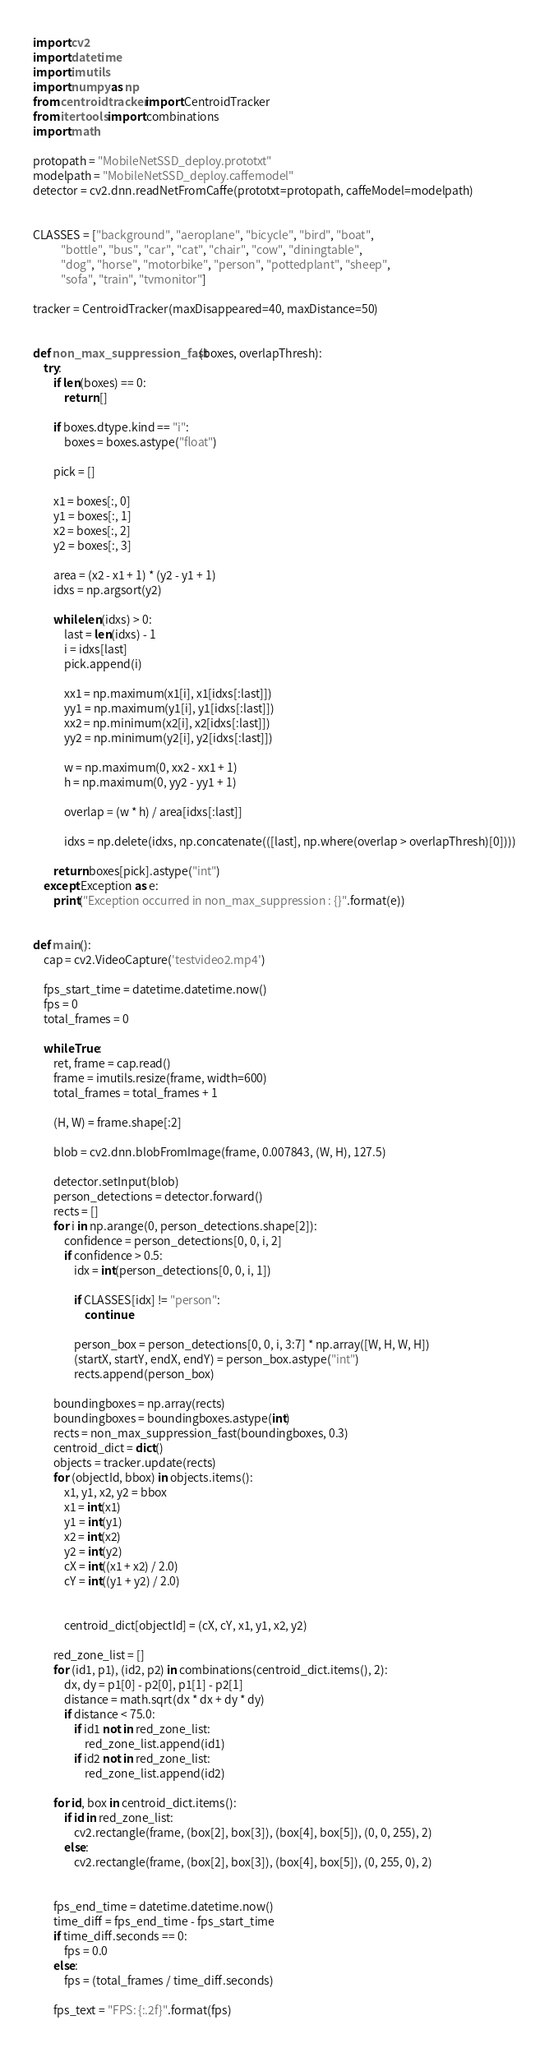Convert code to text. <code><loc_0><loc_0><loc_500><loc_500><_Python_>import cv2
import datetime
import imutils
import numpy as np
from centroidtracker import CentroidTracker
from itertools import combinations
import math

protopath = "MobileNetSSD_deploy.prototxt"
modelpath = "MobileNetSSD_deploy.caffemodel"
detector = cv2.dnn.readNetFromCaffe(prototxt=protopath, caffeModel=modelpath)


CLASSES = ["background", "aeroplane", "bicycle", "bird", "boat",
           "bottle", "bus", "car", "cat", "chair", "cow", "diningtable",
           "dog", "horse", "motorbike", "person", "pottedplant", "sheep",
           "sofa", "train", "tvmonitor"]

tracker = CentroidTracker(maxDisappeared=40, maxDistance=50)


def non_max_suppression_fast(boxes, overlapThresh):
    try:
        if len(boxes) == 0:
            return []

        if boxes.dtype.kind == "i":
            boxes = boxes.astype("float")

        pick = []

        x1 = boxes[:, 0]
        y1 = boxes[:, 1]
        x2 = boxes[:, 2]
        y2 = boxes[:, 3]

        area = (x2 - x1 + 1) * (y2 - y1 + 1)
        idxs = np.argsort(y2)

        while len(idxs) > 0:
            last = len(idxs) - 1
            i = idxs[last]
            pick.append(i)

            xx1 = np.maximum(x1[i], x1[idxs[:last]])
            yy1 = np.maximum(y1[i], y1[idxs[:last]])
            xx2 = np.minimum(x2[i], x2[idxs[:last]])
            yy2 = np.minimum(y2[i], y2[idxs[:last]])

            w = np.maximum(0, xx2 - xx1 + 1)
            h = np.maximum(0, yy2 - yy1 + 1)

            overlap = (w * h) / area[idxs[:last]]

            idxs = np.delete(idxs, np.concatenate(([last], np.where(overlap > overlapThresh)[0])))

        return boxes[pick].astype("int")
    except Exception as e:
        print("Exception occurred in non_max_suppression : {}".format(e))


def main():
    cap = cv2.VideoCapture('testvideo2.mp4')

    fps_start_time = datetime.datetime.now()
    fps = 0
    total_frames = 0

    while True:
        ret, frame = cap.read()
        frame = imutils.resize(frame, width=600)
        total_frames = total_frames + 1

        (H, W) = frame.shape[:2]

        blob = cv2.dnn.blobFromImage(frame, 0.007843, (W, H), 127.5)

        detector.setInput(blob)
        person_detections = detector.forward()
        rects = []
        for i in np.arange(0, person_detections.shape[2]):
            confidence = person_detections[0, 0, i, 2]
            if confidence > 0.5:
                idx = int(person_detections[0, 0, i, 1])

                if CLASSES[idx] != "person":
                    continue

                person_box = person_detections[0, 0, i, 3:7] * np.array([W, H, W, H])
                (startX, startY, endX, endY) = person_box.astype("int")
                rects.append(person_box)

        boundingboxes = np.array(rects)
        boundingboxes = boundingboxes.astype(int)
        rects = non_max_suppression_fast(boundingboxes, 0.3)
        centroid_dict = dict()
        objects = tracker.update(rects)
        for (objectId, bbox) in objects.items():
            x1, y1, x2, y2 = bbox
            x1 = int(x1)
            y1 = int(y1)
            x2 = int(x2)
            y2 = int(y2)
            cX = int((x1 + x2) / 2.0)
            cY = int((y1 + y2) / 2.0)


            centroid_dict[objectId] = (cX, cY, x1, y1, x2, y2)

        red_zone_list = []
        for (id1, p1), (id2, p2) in combinations(centroid_dict.items(), 2):
            dx, dy = p1[0] - p2[0], p1[1] - p2[1]
            distance = math.sqrt(dx * dx + dy * dy)
            if distance < 75.0:
                if id1 not in red_zone_list:
                    red_zone_list.append(id1)
                if id2 not in red_zone_list:
                    red_zone_list.append(id2)

        for id, box in centroid_dict.items():
            if id in red_zone_list:
                cv2.rectangle(frame, (box[2], box[3]), (box[4], box[5]), (0, 0, 255), 2)
            else:
                cv2.rectangle(frame, (box[2], box[3]), (box[4], box[5]), (0, 255, 0), 2)


        fps_end_time = datetime.datetime.now()
        time_diff = fps_end_time - fps_start_time
        if time_diff.seconds == 0:
            fps = 0.0
        else:
            fps = (total_frames / time_diff.seconds)

        fps_text = "FPS: {:.2f}".format(fps)
</code> 